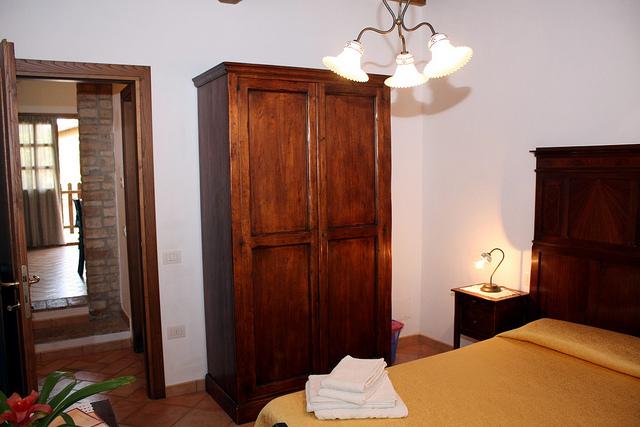Is there a painting on the wall?
Give a very brief answer. No. Where is the lamp?
Quick response, please. Table. What furniture is between the two lamps?
Keep it brief. Bed. Is this house occupied?
Write a very short answer. Yes. What is on top of the bed?
Give a very brief answer. Towels. What room is this?
Concise answer only. Bedroom. How many lamps are pictured?
Short answer required. 1. What color is the bed?
Give a very brief answer. Gold. What color is the dresser next to the bed?
Keep it brief. Brown. Did a lot of money go into building this house?
Quick response, please. Yes. Does this appear to be a personal bedroom or hotel room?
Answer briefly. Hotel room. 